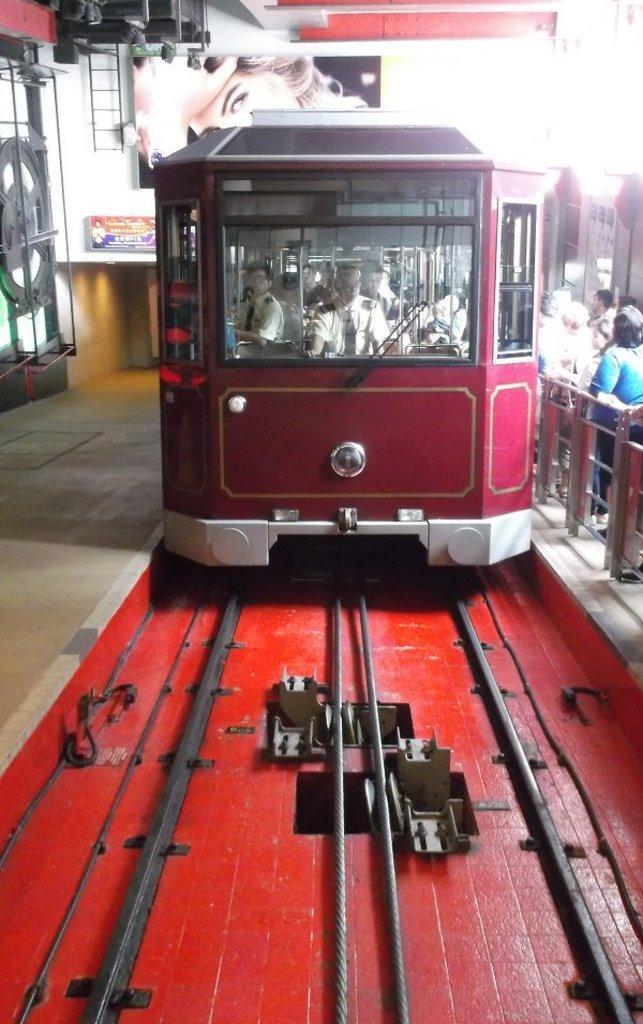How would you summarize this image in a sentence or two? This image consists of a train. It is in red color. There are railway tracks at the bottom. There are some persons on the right side. 